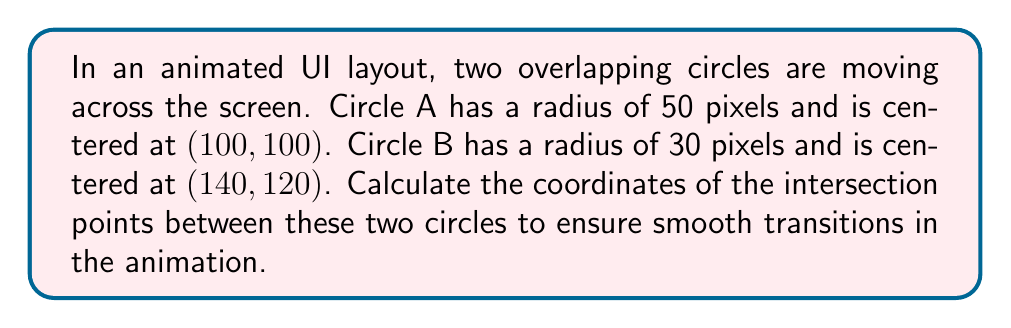Teach me how to tackle this problem. To find the intersection points of two circles, we can follow these steps:

1) Let's define the equations of the two circles:

   Circle A: $$(x-100)^2 + (y-100)^2 = 50^2$$
   Circle B: $$(x-140)^2 + (y-120)^2 = 30^2$$

2) The distance between the centers is:
   $$d = \sqrt{(140-100)^2 + (120-100)^2} = \sqrt{1600} = 40$$

3) We can use the following formulas to find the intersection points:

   $$x = x_1 + \frac{r_1^2 - r_2^2 + d^2}{2d} \cdot \frac{x_2 - x_1}{d} \pm \frac{y_2 - y_1}{d} \cdot h$$
   $$y = y_1 + \frac{r_1^2 - r_2^2 + d^2}{2d} \cdot \frac{y_2 - y_1}{d} \mp \frac{x_2 - x_1}{d} \cdot h$$

   Where $h = \sqrt{r_1^2 - (\frac{r_1^2 - r_2^2 + d^2}{2d})^2}$

4) Plugging in our values:

   $$h = \sqrt{50^2 - (\frac{50^2 - 30^2 + 40^2}{2 \cdot 40})^2} = 24$$

5) Now we can calculate x and y:

   $$x = 100 + \frac{50^2 - 30^2 + 40^2}{2 \cdot 40} \cdot \frac{40}{40} \pm \frac{20}{40} \cdot 24$$
   $$y = 100 + \frac{50^2 - 30^2 + 40^2}{2 \cdot 40} \cdot \frac{20}{40} \mp \frac{40}{40} \cdot 24$$

6) Simplifying:

   $$x = 100 + 27.5 \pm 12 = 127.5 \pm 12$$
   $$y = 100 + 13.75 \mp 24 = 113.75 \mp 24$$

7) This gives us two intersection points:

   $$(127.5 + 12, 113.75 - 24) = (139.5, 89.75)$$
   $$(127.5 - 12, 113.75 + 24) = (115.5, 137.75)$$

[asy]
size(200);
draw(circle((100,100),50));
draw(circle((140,120),30));
dot((139.5,89.75));
dot((115.5,137.75));
label("A", (100,100), SW);
label("B", (140,120), NE);
label("(139.5, 89.75)", (139.5,89.75), SE);
label("(115.5, 137.75)", (115.5,137.75), NW);
[/asy]
Answer: (139.5, 89.75) and (115.5, 137.75) 